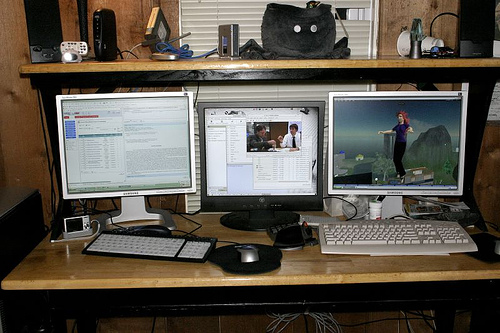<image>
Can you confirm if the mouse is on the desk? Yes. Looking at the image, I can see the mouse is positioned on top of the desk, with the desk providing support. Where is the cup in relation to the wall? Is it on the wall? No. The cup is not positioned on the wall. They may be near each other, but the cup is not supported by or resting on top of the wall. 